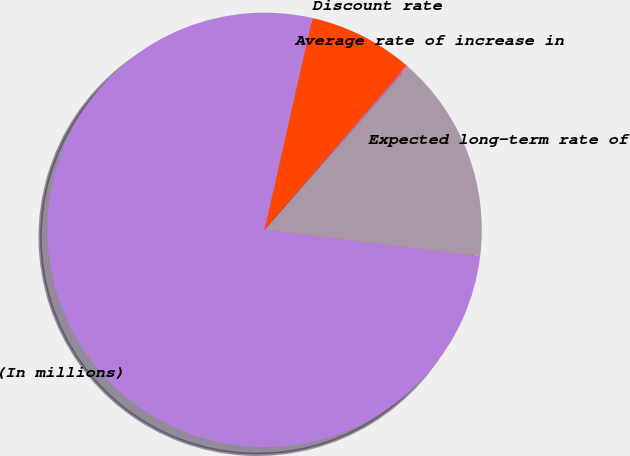Convert chart to OTSL. <chart><loc_0><loc_0><loc_500><loc_500><pie_chart><fcel>(In millions)<fcel>Discount rate<fcel>Average rate of increase in<fcel>Expected long-term rate of<nl><fcel>76.61%<fcel>7.8%<fcel>0.15%<fcel>15.44%<nl></chart> 